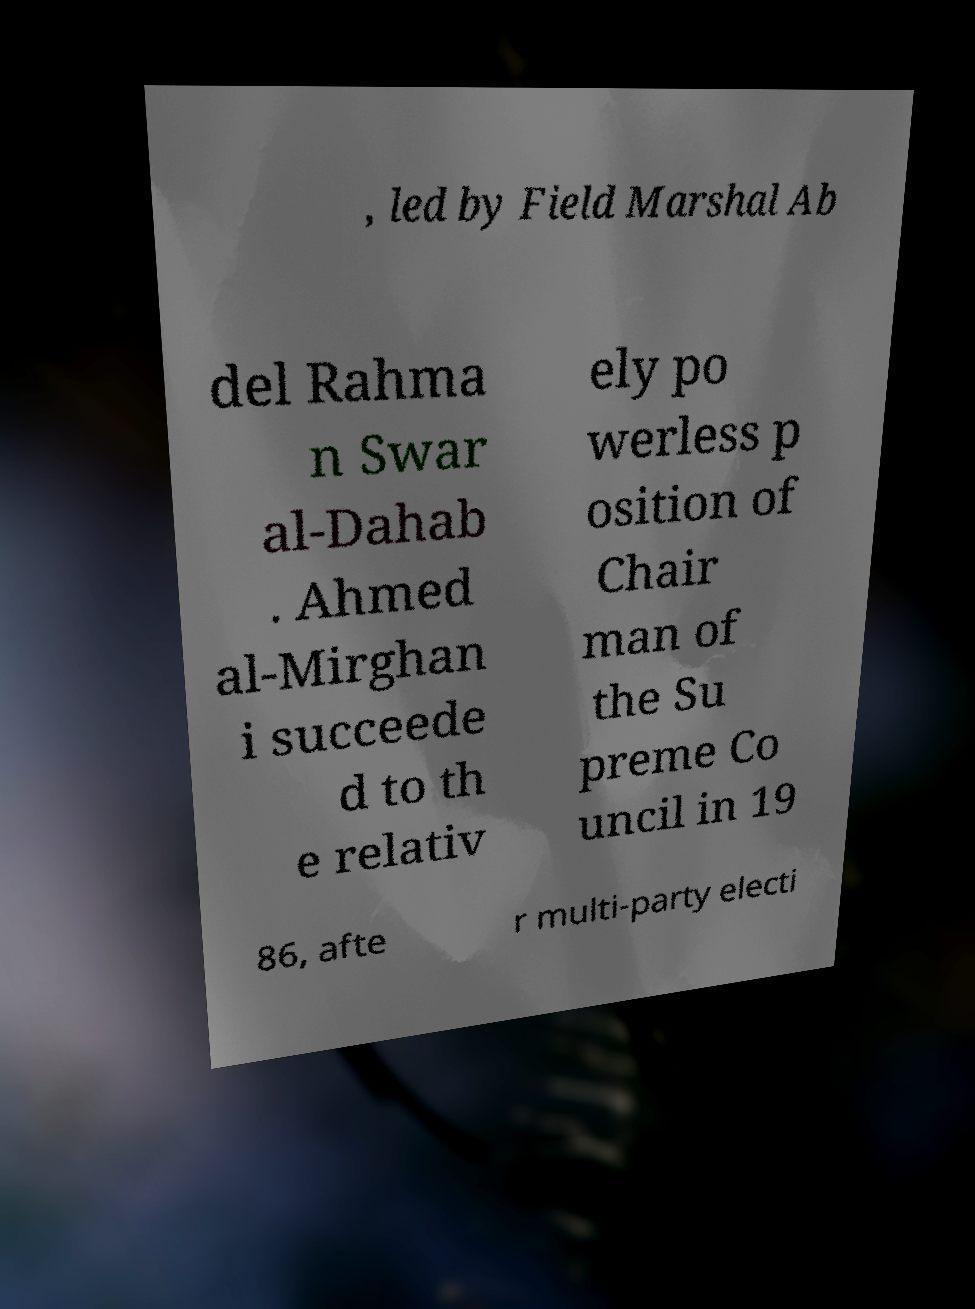Can you read and provide the text displayed in the image?This photo seems to have some interesting text. Can you extract and type it out for me? , led by Field Marshal Ab del Rahma n Swar al-Dahab . Ahmed al-Mirghan i succeede d to th e relativ ely po werless p osition of Chair man of the Su preme Co uncil in 19 86, afte r multi-party electi 